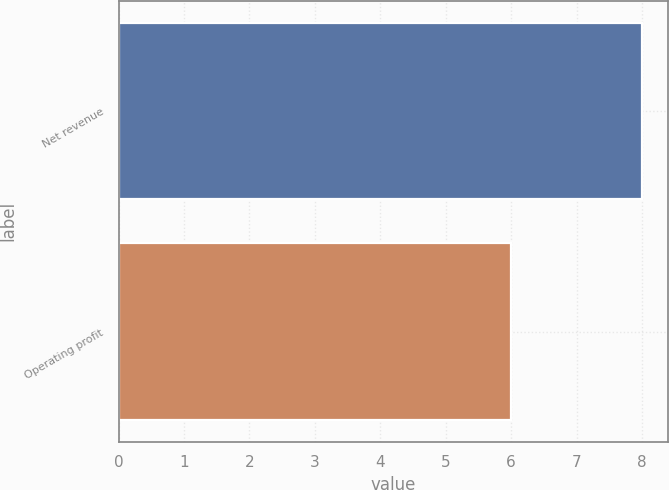<chart> <loc_0><loc_0><loc_500><loc_500><bar_chart><fcel>Net revenue<fcel>Operating profit<nl><fcel>8<fcel>6<nl></chart> 